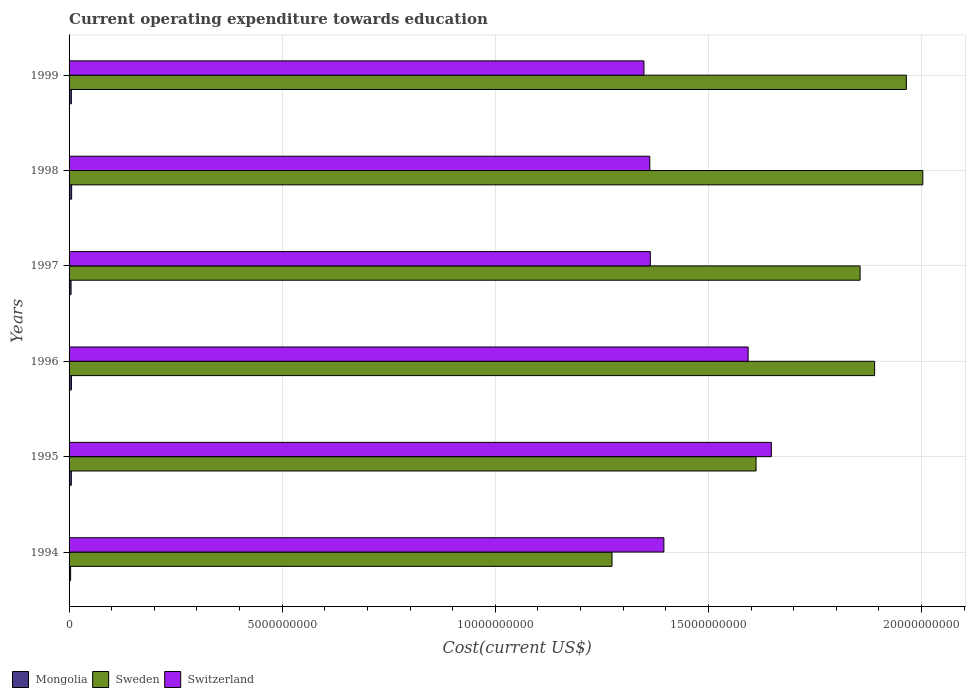How many different coloured bars are there?
Offer a terse response. 3. How many groups of bars are there?
Provide a succinct answer. 6. Are the number of bars per tick equal to the number of legend labels?
Your answer should be compact. Yes. Are the number of bars on each tick of the Y-axis equal?
Offer a terse response. Yes. How many bars are there on the 2nd tick from the top?
Your answer should be compact. 3. How many bars are there on the 3rd tick from the bottom?
Your answer should be very brief. 3. In how many cases, is the number of bars for a given year not equal to the number of legend labels?
Your answer should be very brief. 0. What is the expenditure towards education in Mongolia in 1998?
Offer a very short reply. 6.02e+07. Across all years, what is the maximum expenditure towards education in Sweden?
Offer a terse response. 2.00e+1. Across all years, what is the minimum expenditure towards education in Mongolia?
Make the answer very short. 3.63e+07. What is the total expenditure towards education in Sweden in the graph?
Give a very brief answer. 1.06e+11. What is the difference between the expenditure towards education in Switzerland in 1994 and that in 1995?
Provide a succinct answer. -2.52e+09. What is the difference between the expenditure towards education in Mongolia in 1995 and the expenditure towards education in Switzerland in 1999?
Your answer should be compact. -1.34e+1. What is the average expenditure towards education in Mongolia per year?
Offer a terse response. 5.08e+07. In the year 1994, what is the difference between the expenditure towards education in Sweden and expenditure towards education in Mongolia?
Your answer should be very brief. 1.27e+1. In how many years, is the expenditure towards education in Mongolia greater than 3000000000 US$?
Provide a succinct answer. 0. What is the ratio of the expenditure towards education in Sweden in 1996 to that in 1997?
Ensure brevity in your answer.  1.02. Is the expenditure towards education in Switzerland in 1995 less than that in 1997?
Offer a very short reply. No. What is the difference between the highest and the second highest expenditure towards education in Switzerland?
Offer a terse response. 5.45e+08. What is the difference between the highest and the lowest expenditure towards education in Sweden?
Make the answer very short. 7.29e+09. Is the sum of the expenditure towards education in Mongolia in 1994 and 1998 greater than the maximum expenditure towards education in Switzerland across all years?
Make the answer very short. No. What does the 3rd bar from the top in 1995 represents?
Give a very brief answer. Mongolia. Is it the case that in every year, the sum of the expenditure towards education in Sweden and expenditure towards education in Mongolia is greater than the expenditure towards education in Switzerland?
Provide a succinct answer. No. How many bars are there?
Provide a succinct answer. 18. How many years are there in the graph?
Provide a short and direct response. 6. Are the values on the major ticks of X-axis written in scientific E-notation?
Your response must be concise. No. Does the graph contain any zero values?
Provide a short and direct response. No. Does the graph contain grids?
Provide a short and direct response. Yes. How many legend labels are there?
Your answer should be compact. 3. What is the title of the graph?
Keep it short and to the point. Current operating expenditure towards education. Does "High income: nonOECD" appear as one of the legend labels in the graph?
Keep it short and to the point. No. What is the label or title of the X-axis?
Offer a terse response. Cost(current US$). What is the Cost(current US$) of Mongolia in 1994?
Your answer should be very brief. 3.63e+07. What is the Cost(current US$) in Sweden in 1994?
Your answer should be compact. 1.27e+1. What is the Cost(current US$) of Switzerland in 1994?
Ensure brevity in your answer.  1.40e+1. What is the Cost(current US$) of Mongolia in 1995?
Make the answer very short. 5.27e+07. What is the Cost(current US$) of Sweden in 1995?
Make the answer very short. 1.61e+1. What is the Cost(current US$) in Switzerland in 1995?
Ensure brevity in your answer.  1.65e+1. What is the Cost(current US$) in Mongolia in 1996?
Ensure brevity in your answer.  5.59e+07. What is the Cost(current US$) of Sweden in 1996?
Your answer should be compact. 1.89e+1. What is the Cost(current US$) in Switzerland in 1996?
Keep it short and to the point. 1.59e+1. What is the Cost(current US$) in Mongolia in 1997?
Your response must be concise. 4.68e+07. What is the Cost(current US$) of Sweden in 1997?
Provide a short and direct response. 1.86e+1. What is the Cost(current US$) in Switzerland in 1997?
Your answer should be compact. 1.36e+1. What is the Cost(current US$) in Mongolia in 1998?
Provide a succinct answer. 6.02e+07. What is the Cost(current US$) in Sweden in 1998?
Offer a terse response. 2.00e+1. What is the Cost(current US$) of Switzerland in 1998?
Your response must be concise. 1.36e+1. What is the Cost(current US$) of Mongolia in 1999?
Offer a terse response. 5.32e+07. What is the Cost(current US$) in Sweden in 1999?
Ensure brevity in your answer.  1.96e+1. What is the Cost(current US$) in Switzerland in 1999?
Keep it short and to the point. 1.35e+1. Across all years, what is the maximum Cost(current US$) in Mongolia?
Provide a succinct answer. 6.02e+07. Across all years, what is the maximum Cost(current US$) of Sweden?
Give a very brief answer. 2.00e+1. Across all years, what is the maximum Cost(current US$) in Switzerland?
Provide a succinct answer. 1.65e+1. Across all years, what is the minimum Cost(current US$) in Mongolia?
Provide a short and direct response. 3.63e+07. Across all years, what is the minimum Cost(current US$) in Sweden?
Provide a succinct answer. 1.27e+1. Across all years, what is the minimum Cost(current US$) of Switzerland?
Make the answer very short. 1.35e+1. What is the total Cost(current US$) of Mongolia in the graph?
Ensure brevity in your answer.  3.05e+08. What is the total Cost(current US$) of Sweden in the graph?
Provide a short and direct response. 1.06e+11. What is the total Cost(current US$) of Switzerland in the graph?
Provide a short and direct response. 8.71e+1. What is the difference between the Cost(current US$) in Mongolia in 1994 and that in 1995?
Make the answer very short. -1.65e+07. What is the difference between the Cost(current US$) of Sweden in 1994 and that in 1995?
Your answer should be very brief. -3.38e+09. What is the difference between the Cost(current US$) of Switzerland in 1994 and that in 1995?
Your answer should be very brief. -2.52e+09. What is the difference between the Cost(current US$) in Mongolia in 1994 and that in 1996?
Your response must be concise. -1.97e+07. What is the difference between the Cost(current US$) of Sweden in 1994 and that in 1996?
Your answer should be very brief. -6.16e+09. What is the difference between the Cost(current US$) of Switzerland in 1994 and that in 1996?
Give a very brief answer. -1.98e+09. What is the difference between the Cost(current US$) of Mongolia in 1994 and that in 1997?
Make the answer very short. -1.05e+07. What is the difference between the Cost(current US$) in Sweden in 1994 and that in 1997?
Offer a terse response. -5.82e+09. What is the difference between the Cost(current US$) in Switzerland in 1994 and that in 1997?
Give a very brief answer. 3.19e+08. What is the difference between the Cost(current US$) of Mongolia in 1994 and that in 1998?
Provide a succinct answer. -2.39e+07. What is the difference between the Cost(current US$) in Sweden in 1994 and that in 1998?
Keep it short and to the point. -7.29e+09. What is the difference between the Cost(current US$) in Switzerland in 1994 and that in 1998?
Provide a succinct answer. 3.31e+08. What is the difference between the Cost(current US$) of Mongolia in 1994 and that in 1999?
Offer a very short reply. -1.70e+07. What is the difference between the Cost(current US$) in Sweden in 1994 and that in 1999?
Your answer should be very brief. -6.91e+09. What is the difference between the Cost(current US$) in Switzerland in 1994 and that in 1999?
Your answer should be compact. 4.68e+08. What is the difference between the Cost(current US$) in Mongolia in 1995 and that in 1996?
Your answer should be very brief. -3.18e+06. What is the difference between the Cost(current US$) of Sweden in 1995 and that in 1996?
Ensure brevity in your answer.  -2.78e+09. What is the difference between the Cost(current US$) in Switzerland in 1995 and that in 1996?
Offer a terse response. 5.45e+08. What is the difference between the Cost(current US$) of Mongolia in 1995 and that in 1997?
Your answer should be compact. 5.98e+06. What is the difference between the Cost(current US$) in Sweden in 1995 and that in 1997?
Ensure brevity in your answer.  -2.44e+09. What is the difference between the Cost(current US$) of Switzerland in 1995 and that in 1997?
Keep it short and to the point. 2.84e+09. What is the difference between the Cost(current US$) in Mongolia in 1995 and that in 1998?
Give a very brief answer. -7.45e+06. What is the difference between the Cost(current US$) of Sweden in 1995 and that in 1998?
Offer a terse response. -3.91e+09. What is the difference between the Cost(current US$) of Switzerland in 1995 and that in 1998?
Your response must be concise. 2.85e+09. What is the difference between the Cost(current US$) in Mongolia in 1995 and that in 1999?
Ensure brevity in your answer.  -4.72e+05. What is the difference between the Cost(current US$) of Sweden in 1995 and that in 1999?
Provide a short and direct response. -3.53e+09. What is the difference between the Cost(current US$) in Switzerland in 1995 and that in 1999?
Offer a terse response. 2.99e+09. What is the difference between the Cost(current US$) of Mongolia in 1996 and that in 1997?
Give a very brief answer. 9.16e+06. What is the difference between the Cost(current US$) in Sweden in 1996 and that in 1997?
Give a very brief answer. 3.40e+08. What is the difference between the Cost(current US$) in Switzerland in 1996 and that in 1997?
Your answer should be compact. 2.29e+09. What is the difference between the Cost(current US$) of Mongolia in 1996 and that in 1998?
Your response must be concise. -4.27e+06. What is the difference between the Cost(current US$) of Sweden in 1996 and that in 1998?
Your response must be concise. -1.13e+09. What is the difference between the Cost(current US$) of Switzerland in 1996 and that in 1998?
Provide a short and direct response. 2.31e+09. What is the difference between the Cost(current US$) of Mongolia in 1996 and that in 1999?
Provide a short and direct response. 2.71e+06. What is the difference between the Cost(current US$) of Sweden in 1996 and that in 1999?
Keep it short and to the point. -7.45e+08. What is the difference between the Cost(current US$) in Switzerland in 1996 and that in 1999?
Your answer should be very brief. 2.44e+09. What is the difference between the Cost(current US$) in Mongolia in 1997 and that in 1998?
Your answer should be compact. -1.34e+07. What is the difference between the Cost(current US$) in Sweden in 1997 and that in 1998?
Make the answer very short. -1.47e+09. What is the difference between the Cost(current US$) of Switzerland in 1997 and that in 1998?
Keep it short and to the point. 1.22e+07. What is the difference between the Cost(current US$) of Mongolia in 1997 and that in 1999?
Your answer should be compact. -6.45e+06. What is the difference between the Cost(current US$) in Sweden in 1997 and that in 1999?
Give a very brief answer. -1.09e+09. What is the difference between the Cost(current US$) of Switzerland in 1997 and that in 1999?
Offer a terse response. 1.50e+08. What is the difference between the Cost(current US$) in Mongolia in 1998 and that in 1999?
Make the answer very short. 6.98e+06. What is the difference between the Cost(current US$) of Sweden in 1998 and that in 1999?
Your answer should be very brief. 3.86e+08. What is the difference between the Cost(current US$) in Switzerland in 1998 and that in 1999?
Your answer should be compact. 1.38e+08. What is the difference between the Cost(current US$) in Mongolia in 1994 and the Cost(current US$) in Sweden in 1995?
Make the answer very short. -1.61e+1. What is the difference between the Cost(current US$) of Mongolia in 1994 and the Cost(current US$) of Switzerland in 1995?
Your answer should be compact. -1.64e+1. What is the difference between the Cost(current US$) of Sweden in 1994 and the Cost(current US$) of Switzerland in 1995?
Provide a succinct answer. -3.74e+09. What is the difference between the Cost(current US$) of Mongolia in 1994 and the Cost(current US$) of Sweden in 1996?
Keep it short and to the point. -1.89e+1. What is the difference between the Cost(current US$) in Mongolia in 1994 and the Cost(current US$) in Switzerland in 1996?
Keep it short and to the point. -1.59e+1. What is the difference between the Cost(current US$) in Sweden in 1994 and the Cost(current US$) in Switzerland in 1996?
Your response must be concise. -3.19e+09. What is the difference between the Cost(current US$) of Mongolia in 1994 and the Cost(current US$) of Sweden in 1997?
Give a very brief answer. -1.85e+1. What is the difference between the Cost(current US$) in Mongolia in 1994 and the Cost(current US$) in Switzerland in 1997?
Offer a terse response. -1.36e+1. What is the difference between the Cost(current US$) of Sweden in 1994 and the Cost(current US$) of Switzerland in 1997?
Ensure brevity in your answer.  -8.98e+08. What is the difference between the Cost(current US$) of Mongolia in 1994 and the Cost(current US$) of Sweden in 1998?
Keep it short and to the point. -2.00e+1. What is the difference between the Cost(current US$) of Mongolia in 1994 and the Cost(current US$) of Switzerland in 1998?
Provide a short and direct response. -1.36e+1. What is the difference between the Cost(current US$) of Sweden in 1994 and the Cost(current US$) of Switzerland in 1998?
Your response must be concise. -8.86e+08. What is the difference between the Cost(current US$) in Mongolia in 1994 and the Cost(current US$) in Sweden in 1999?
Your answer should be compact. -1.96e+1. What is the difference between the Cost(current US$) in Mongolia in 1994 and the Cost(current US$) in Switzerland in 1999?
Provide a short and direct response. -1.35e+1. What is the difference between the Cost(current US$) of Sweden in 1994 and the Cost(current US$) of Switzerland in 1999?
Your response must be concise. -7.49e+08. What is the difference between the Cost(current US$) in Mongolia in 1995 and the Cost(current US$) in Sweden in 1996?
Make the answer very short. -1.88e+1. What is the difference between the Cost(current US$) of Mongolia in 1995 and the Cost(current US$) of Switzerland in 1996?
Make the answer very short. -1.59e+1. What is the difference between the Cost(current US$) in Sweden in 1995 and the Cost(current US$) in Switzerland in 1996?
Give a very brief answer. 1.86e+08. What is the difference between the Cost(current US$) of Mongolia in 1995 and the Cost(current US$) of Sweden in 1997?
Keep it short and to the point. -1.85e+1. What is the difference between the Cost(current US$) of Mongolia in 1995 and the Cost(current US$) of Switzerland in 1997?
Offer a terse response. -1.36e+1. What is the difference between the Cost(current US$) of Sweden in 1995 and the Cost(current US$) of Switzerland in 1997?
Make the answer very short. 2.48e+09. What is the difference between the Cost(current US$) in Mongolia in 1995 and the Cost(current US$) in Sweden in 1998?
Your answer should be very brief. -2.00e+1. What is the difference between the Cost(current US$) in Mongolia in 1995 and the Cost(current US$) in Switzerland in 1998?
Ensure brevity in your answer.  -1.36e+1. What is the difference between the Cost(current US$) in Sweden in 1995 and the Cost(current US$) in Switzerland in 1998?
Offer a terse response. 2.49e+09. What is the difference between the Cost(current US$) of Mongolia in 1995 and the Cost(current US$) of Sweden in 1999?
Provide a succinct answer. -1.96e+1. What is the difference between the Cost(current US$) in Mongolia in 1995 and the Cost(current US$) in Switzerland in 1999?
Provide a succinct answer. -1.34e+1. What is the difference between the Cost(current US$) of Sweden in 1995 and the Cost(current US$) of Switzerland in 1999?
Make the answer very short. 2.63e+09. What is the difference between the Cost(current US$) of Mongolia in 1996 and the Cost(current US$) of Sweden in 1997?
Provide a succinct answer. -1.85e+1. What is the difference between the Cost(current US$) of Mongolia in 1996 and the Cost(current US$) of Switzerland in 1997?
Your answer should be compact. -1.36e+1. What is the difference between the Cost(current US$) in Sweden in 1996 and the Cost(current US$) in Switzerland in 1997?
Offer a very short reply. 5.26e+09. What is the difference between the Cost(current US$) of Mongolia in 1996 and the Cost(current US$) of Sweden in 1998?
Provide a succinct answer. -2.00e+1. What is the difference between the Cost(current US$) in Mongolia in 1996 and the Cost(current US$) in Switzerland in 1998?
Provide a succinct answer. -1.36e+1. What is the difference between the Cost(current US$) in Sweden in 1996 and the Cost(current US$) in Switzerland in 1998?
Your answer should be very brief. 5.27e+09. What is the difference between the Cost(current US$) in Mongolia in 1996 and the Cost(current US$) in Sweden in 1999?
Your response must be concise. -1.96e+1. What is the difference between the Cost(current US$) of Mongolia in 1996 and the Cost(current US$) of Switzerland in 1999?
Keep it short and to the point. -1.34e+1. What is the difference between the Cost(current US$) in Sweden in 1996 and the Cost(current US$) in Switzerland in 1999?
Offer a terse response. 5.41e+09. What is the difference between the Cost(current US$) of Mongolia in 1997 and the Cost(current US$) of Sweden in 1998?
Your answer should be compact. -2.00e+1. What is the difference between the Cost(current US$) of Mongolia in 1997 and the Cost(current US$) of Switzerland in 1998?
Your response must be concise. -1.36e+1. What is the difference between the Cost(current US$) in Sweden in 1997 and the Cost(current US$) in Switzerland in 1998?
Ensure brevity in your answer.  4.93e+09. What is the difference between the Cost(current US$) of Mongolia in 1997 and the Cost(current US$) of Sweden in 1999?
Provide a short and direct response. -1.96e+1. What is the difference between the Cost(current US$) of Mongolia in 1997 and the Cost(current US$) of Switzerland in 1999?
Your response must be concise. -1.34e+1. What is the difference between the Cost(current US$) of Sweden in 1997 and the Cost(current US$) of Switzerland in 1999?
Ensure brevity in your answer.  5.07e+09. What is the difference between the Cost(current US$) of Mongolia in 1998 and the Cost(current US$) of Sweden in 1999?
Keep it short and to the point. -1.96e+1. What is the difference between the Cost(current US$) in Mongolia in 1998 and the Cost(current US$) in Switzerland in 1999?
Ensure brevity in your answer.  -1.34e+1. What is the difference between the Cost(current US$) of Sweden in 1998 and the Cost(current US$) of Switzerland in 1999?
Provide a succinct answer. 6.54e+09. What is the average Cost(current US$) in Mongolia per year?
Your answer should be very brief. 5.08e+07. What is the average Cost(current US$) in Sweden per year?
Provide a succinct answer. 1.77e+1. What is the average Cost(current US$) in Switzerland per year?
Your answer should be very brief. 1.45e+1. In the year 1994, what is the difference between the Cost(current US$) in Mongolia and Cost(current US$) in Sweden?
Give a very brief answer. -1.27e+1. In the year 1994, what is the difference between the Cost(current US$) of Mongolia and Cost(current US$) of Switzerland?
Your answer should be compact. -1.39e+1. In the year 1994, what is the difference between the Cost(current US$) in Sweden and Cost(current US$) in Switzerland?
Provide a short and direct response. -1.22e+09. In the year 1995, what is the difference between the Cost(current US$) of Mongolia and Cost(current US$) of Sweden?
Offer a very short reply. -1.61e+1. In the year 1995, what is the difference between the Cost(current US$) of Mongolia and Cost(current US$) of Switzerland?
Offer a very short reply. -1.64e+1. In the year 1995, what is the difference between the Cost(current US$) of Sweden and Cost(current US$) of Switzerland?
Your answer should be compact. -3.59e+08. In the year 1996, what is the difference between the Cost(current US$) of Mongolia and Cost(current US$) of Sweden?
Provide a succinct answer. -1.88e+1. In the year 1996, what is the difference between the Cost(current US$) in Mongolia and Cost(current US$) in Switzerland?
Your answer should be very brief. -1.59e+1. In the year 1996, what is the difference between the Cost(current US$) of Sweden and Cost(current US$) of Switzerland?
Ensure brevity in your answer.  2.97e+09. In the year 1997, what is the difference between the Cost(current US$) of Mongolia and Cost(current US$) of Sweden?
Provide a succinct answer. -1.85e+1. In the year 1997, what is the difference between the Cost(current US$) of Mongolia and Cost(current US$) of Switzerland?
Give a very brief answer. -1.36e+1. In the year 1997, what is the difference between the Cost(current US$) of Sweden and Cost(current US$) of Switzerland?
Your answer should be compact. 4.92e+09. In the year 1998, what is the difference between the Cost(current US$) of Mongolia and Cost(current US$) of Sweden?
Your answer should be very brief. -2.00e+1. In the year 1998, what is the difference between the Cost(current US$) in Mongolia and Cost(current US$) in Switzerland?
Offer a very short reply. -1.36e+1. In the year 1998, what is the difference between the Cost(current US$) of Sweden and Cost(current US$) of Switzerland?
Your answer should be very brief. 6.40e+09. In the year 1999, what is the difference between the Cost(current US$) in Mongolia and Cost(current US$) in Sweden?
Offer a very short reply. -1.96e+1. In the year 1999, what is the difference between the Cost(current US$) of Mongolia and Cost(current US$) of Switzerland?
Provide a short and direct response. -1.34e+1. In the year 1999, what is the difference between the Cost(current US$) of Sweden and Cost(current US$) of Switzerland?
Provide a short and direct response. 6.16e+09. What is the ratio of the Cost(current US$) of Mongolia in 1994 to that in 1995?
Your answer should be compact. 0.69. What is the ratio of the Cost(current US$) in Sweden in 1994 to that in 1995?
Your response must be concise. 0.79. What is the ratio of the Cost(current US$) of Switzerland in 1994 to that in 1995?
Your answer should be very brief. 0.85. What is the ratio of the Cost(current US$) of Mongolia in 1994 to that in 1996?
Your answer should be compact. 0.65. What is the ratio of the Cost(current US$) of Sweden in 1994 to that in 1996?
Keep it short and to the point. 0.67. What is the ratio of the Cost(current US$) in Switzerland in 1994 to that in 1996?
Keep it short and to the point. 0.88. What is the ratio of the Cost(current US$) of Mongolia in 1994 to that in 1997?
Offer a terse response. 0.78. What is the ratio of the Cost(current US$) in Sweden in 1994 to that in 1997?
Make the answer very short. 0.69. What is the ratio of the Cost(current US$) of Switzerland in 1994 to that in 1997?
Offer a terse response. 1.02. What is the ratio of the Cost(current US$) in Mongolia in 1994 to that in 1998?
Offer a terse response. 0.6. What is the ratio of the Cost(current US$) of Sweden in 1994 to that in 1998?
Make the answer very short. 0.64. What is the ratio of the Cost(current US$) of Switzerland in 1994 to that in 1998?
Provide a succinct answer. 1.02. What is the ratio of the Cost(current US$) of Mongolia in 1994 to that in 1999?
Offer a terse response. 0.68. What is the ratio of the Cost(current US$) of Sweden in 1994 to that in 1999?
Offer a terse response. 0.65. What is the ratio of the Cost(current US$) of Switzerland in 1994 to that in 1999?
Your response must be concise. 1.03. What is the ratio of the Cost(current US$) in Mongolia in 1995 to that in 1996?
Offer a very short reply. 0.94. What is the ratio of the Cost(current US$) in Sweden in 1995 to that in 1996?
Your answer should be very brief. 0.85. What is the ratio of the Cost(current US$) in Switzerland in 1995 to that in 1996?
Your response must be concise. 1.03. What is the ratio of the Cost(current US$) of Mongolia in 1995 to that in 1997?
Offer a terse response. 1.13. What is the ratio of the Cost(current US$) of Sweden in 1995 to that in 1997?
Offer a terse response. 0.87. What is the ratio of the Cost(current US$) of Switzerland in 1995 to that in 1997?
Your answer should be compact. 1.21. What is the ratio of the Cost(current US$) in Mongolia in 1995 to that in 1998?
Give a very brief answer. 0.88. What is the ratio of the Cost(current US$) of Sweden in 1995 to that in 1998?
Your response must be concise. 0.8. What is the ratio of the Cost(current US$) of Switzerland in 1995 to that in 1998?
Your answer should be compact. 1.21. What is the ratio of the Cost(current US$) in Mongolia in 1995 to that in 1999?
Make the answer very short. 0.99. What is the ratio of the Cost(current US$) in Sweden in 1995 to that in 1999?
Provide a short and direct response. 0.82. What is the ratio of the Cost(current US$) of Switzerland in 1995 to that in 1999?
Offer a very short reply. 1.22. What is the ratio of the Cost(current US$) in Mongolia in 1996 to that in 1997?
Ensure brevity in your answer.  1.2. What is the ratio of the Cost(current US$) of Sweden in 1996 to that in 1997?
Keep it short and to the point. 1.02. What is the ratio of the Cost(current US$) in Switzerland in 1996 to that in 1997?
Offer a terse response. 1.17. What is the ratio of the Cost(current US$) of Mongolia in 1996 to that in 1998?
Your answer should be compact. 0.93. What is the ratio of the Cost(current US$) of Sweden in 1996 to that in 1998?
Offer a very short reply. 0.94. What is the ratio of the Cost(current US$) of Switzerland in 1996 to that in 1998?
Make the answer very short. 1.17. What is the ratio of the Cost(current US$) in Mongolia in 1996 to that in 1999?
Ensure brevity in your answer.  1.05. What is the ratio of the Cost(current US$) in Sweden in 1996 to that in 1999?
Your answer should be compact. 0.96. What is the ratio of the Cost(current US$) of Switzerland in 1996 to that in 1999?
Offer a terse response. 1.18. What is the ratio of the Cost(current US$) of Mongolia in 1997 to that in 1998?
Give a very brief answer. 0.78. What is the ratio of the Cost(current US$) of Sweden in 1997 to that in 1998?
Make the answer very short. 0.93. What is the ratio of the Cost(current US$) in Mongolia in 1997 to that in 1999?
Offer a very short reply. 0.88. What is the ratio of the Cost(current US$) of Sweden in 1997 to that in 1999?
Your response must be concise. 0.94. What is the ratio of the Cost(current US$) in Switzerland in 1997 to that in 1999?
Provide a short and direct response. 1.01. What is the ratio of the Cost(current US$) of Mongolia in 1998 to that in 1999?
Your response must be concise. 1.13. What is the ratio of the Cost(current US$) in Sweden in 1998 to that in 1999?
Ensure brevity in your answer.  1.02. What is the ratio of the Cost(current US$) in Switzerland in 1998 to that in 1999?
Your response must be concise. 1.01. What is the difference between the highest and the second highest Cost(current US$) in Mongolia?
Provide a succinct answer. 4.27e+06. What is the difference between the highest and the second highest Cost(current US$) in Sweden?
Give a very brief answer. 3.86e+08. What is the difference between the highest and the second highest Cost(current US$) of Switzerland?
Provide a short and direct response. 5.45e+08. What is the difference between the highest and the lowest Cost(current US$) of Mongolia?
Offer a very short reply. 2.39e+07. What is the difference between the highest and the lowest Cost(current US$) of Sweden?
Ensure brevity in your answer.  7.29e+09. What is the difference between the highest and the lowest Cost(current US$) of Switzerland?
Provide a short and direct response. 2.99e+09. 